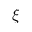Convert formula to latex. <formula><loc_0><loc_0><loc_500><loc_500>\xi</formula> 